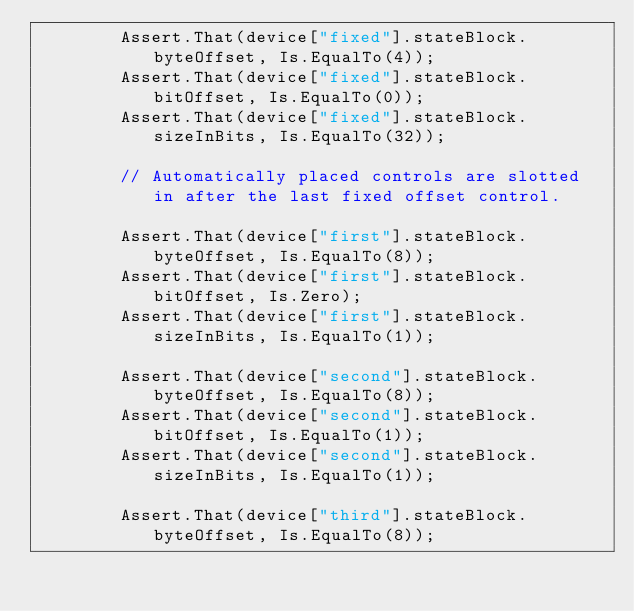<code> <loc_0><loc_0><loc_500><loc_500><_C#_>        Assert.That(device["fixed"].stateBlock.byteOffset, Is.EqualTo(4));
        Assert.That(device["fixed"].stateBlock.bitOffset, Is.EqualTo(0));
        Assert.That(device["fixed"].stateBlock.sizeInBits, Is.EqualTo(32));

        // Automatically placed controls are slotted in after the last fixed offset control.

        Assert.That(device["first"].stateBlock.byteOffset, Is.EqualTo(8));
        Assert.That(device["first"].stateBlock.bitOffset, Is.Zero);
        Assert.That(device["first"].stateBlock.sizeInBits, Is.EqualTo(1));

        Assert.That(device["second"].stateBlock.byteOffset, Is.EqualTo(8));
        Assert.That(device["second"].stateBlock.bitOffset, Is.EqualTo(1));
        Assert.That(device["second"].stateBlock.sizeInBits, Is.EqualTo(1));

        Assert.That(device["third"].stateBlock.byteOffset, Is.EqualTo(8));</code> 